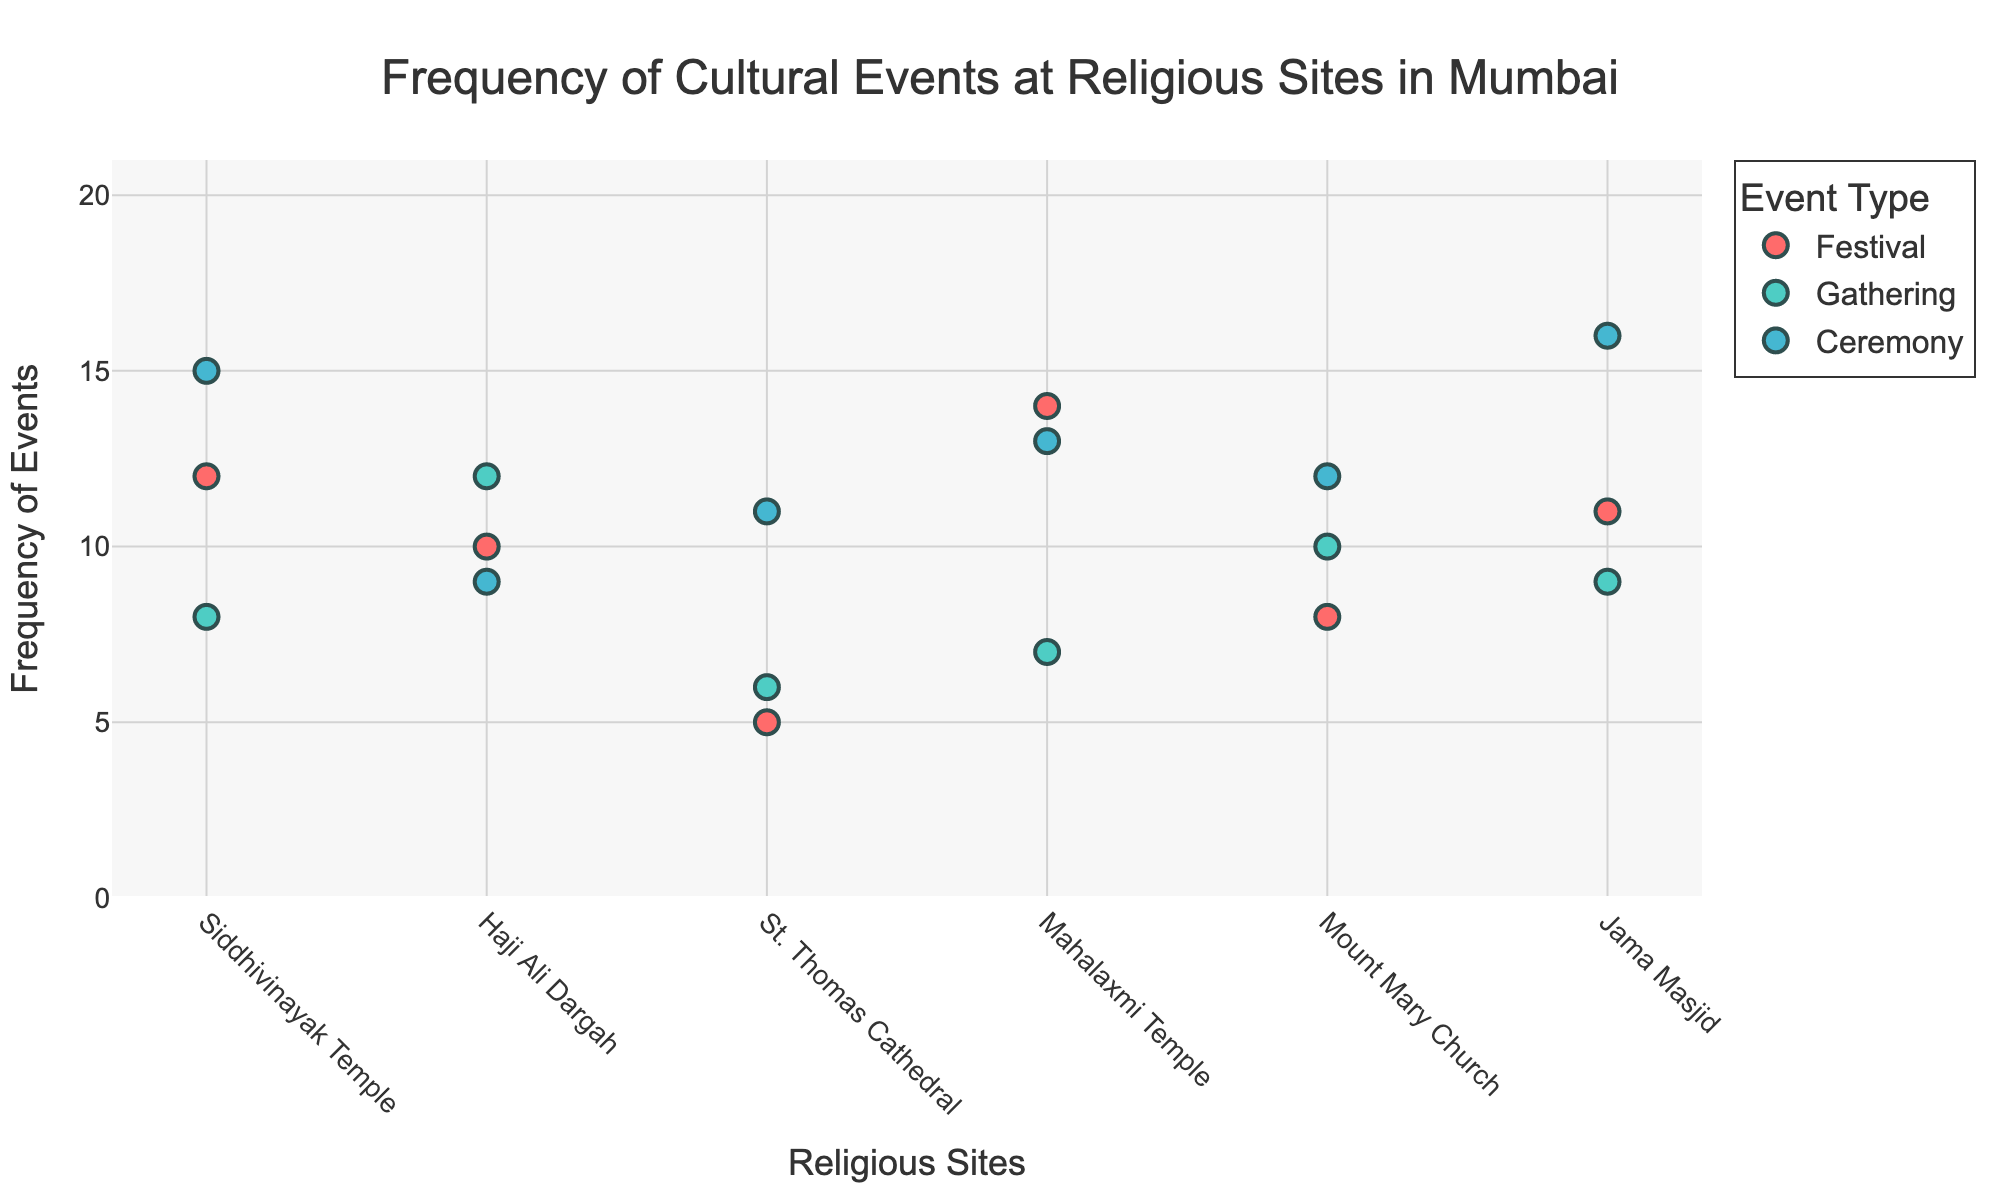What is the title of the figure? The title is shown at the top of the figure and describes the content of the plot.
Answer: Frequency of Cultural Events at Religious Sites in Mumbai Which religious site has the highest frequency of ceremonies? Look for the largest y-axis value under the "Ceremony" category for each site on the x-axis.
Answer: Jama Masjid How many events are categorized under "Festival" at Siddhivinayak Temple? Locate Siddhivinayak Temple on the x-axis and find the "Festival" data point, check the y-axis value.
Answer: 12 Which event type is represented with the color red? Observe the legend on the plot to see the color assignment for each event type.
Answer: Festival Between Haji Ali Dargah and Mount Mary Church, which site has a higher frequency of gatherings? Compare the y-axis values of the "Gathering" data points for both Haji Ali Dargah and Mount Mary Church.
Answer: Haji Ali Dargah What is the average frequency of events at Mahalaxmi Temple across all event types? Add the frequencies for all event types at Mahalaxmi Temple and divide by the number of event types. (14 + 7 + 13) / 3 = 11.33
Answer: 11.33 Which religious site has the lowest frequency of festivals? Identify the religious site with the smallest y-axis value under the "Festival" category.
Answer: St. Thomas Cathedral What is the difference in frequency of ceremonies between Siddhivinayak Temple and Jama Masjid? Subtract the frequency of ceremonies at Siddhivinayak Temple from that at Jama Masjid. 16 - 15 = 1
Answer: 1 How many types of events are recorded at each religious site? Count the number of unique event types (Festival, Gathering, Ceremony) represented for each religious site.
Answer: 3 Which event type has the most overall frequency across all sites? Sum the frequencies for each event type across all sites and compare the totals. Ceremony: 76, Festival: 60, Gathering: 52, so Ceremony has the most.
Answer: Ceremony 